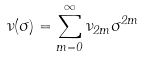Convert formula to latex. <formula><loc_0><loc_0><loc_500><loc_500>\nu ( \sigma ) = \sum _ { m = 0 } ^ { \infty } \nu _ { 2 m } \sigma ^ { 2 m }</formula> 